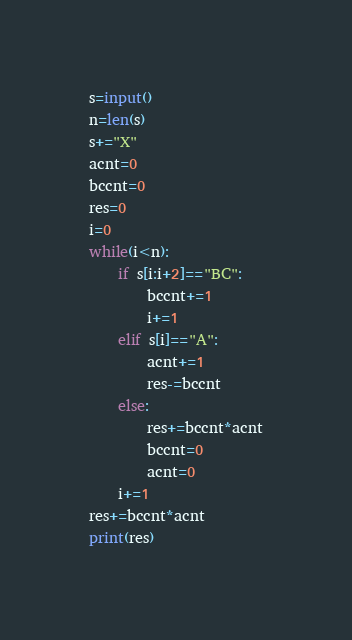Convert code to text. <code><loc_0><loc_0><loc_500><loc_500><_Python_>s=input()
n=len(s)
s+="X"
acnt=0
bccnt=0
res=0
i=0
while(i<n):
    if s[i:i+2]=="BC":
        bccnt+=1
        i+=1
    elif s[i]=="A":
        acnt+=1
        res-=bccnt
    else:
        res+=bccnt*acnt
        bccnt=0
        acnt=0
    i+=1
res+=bccnt*acnt
print(res)</code> 